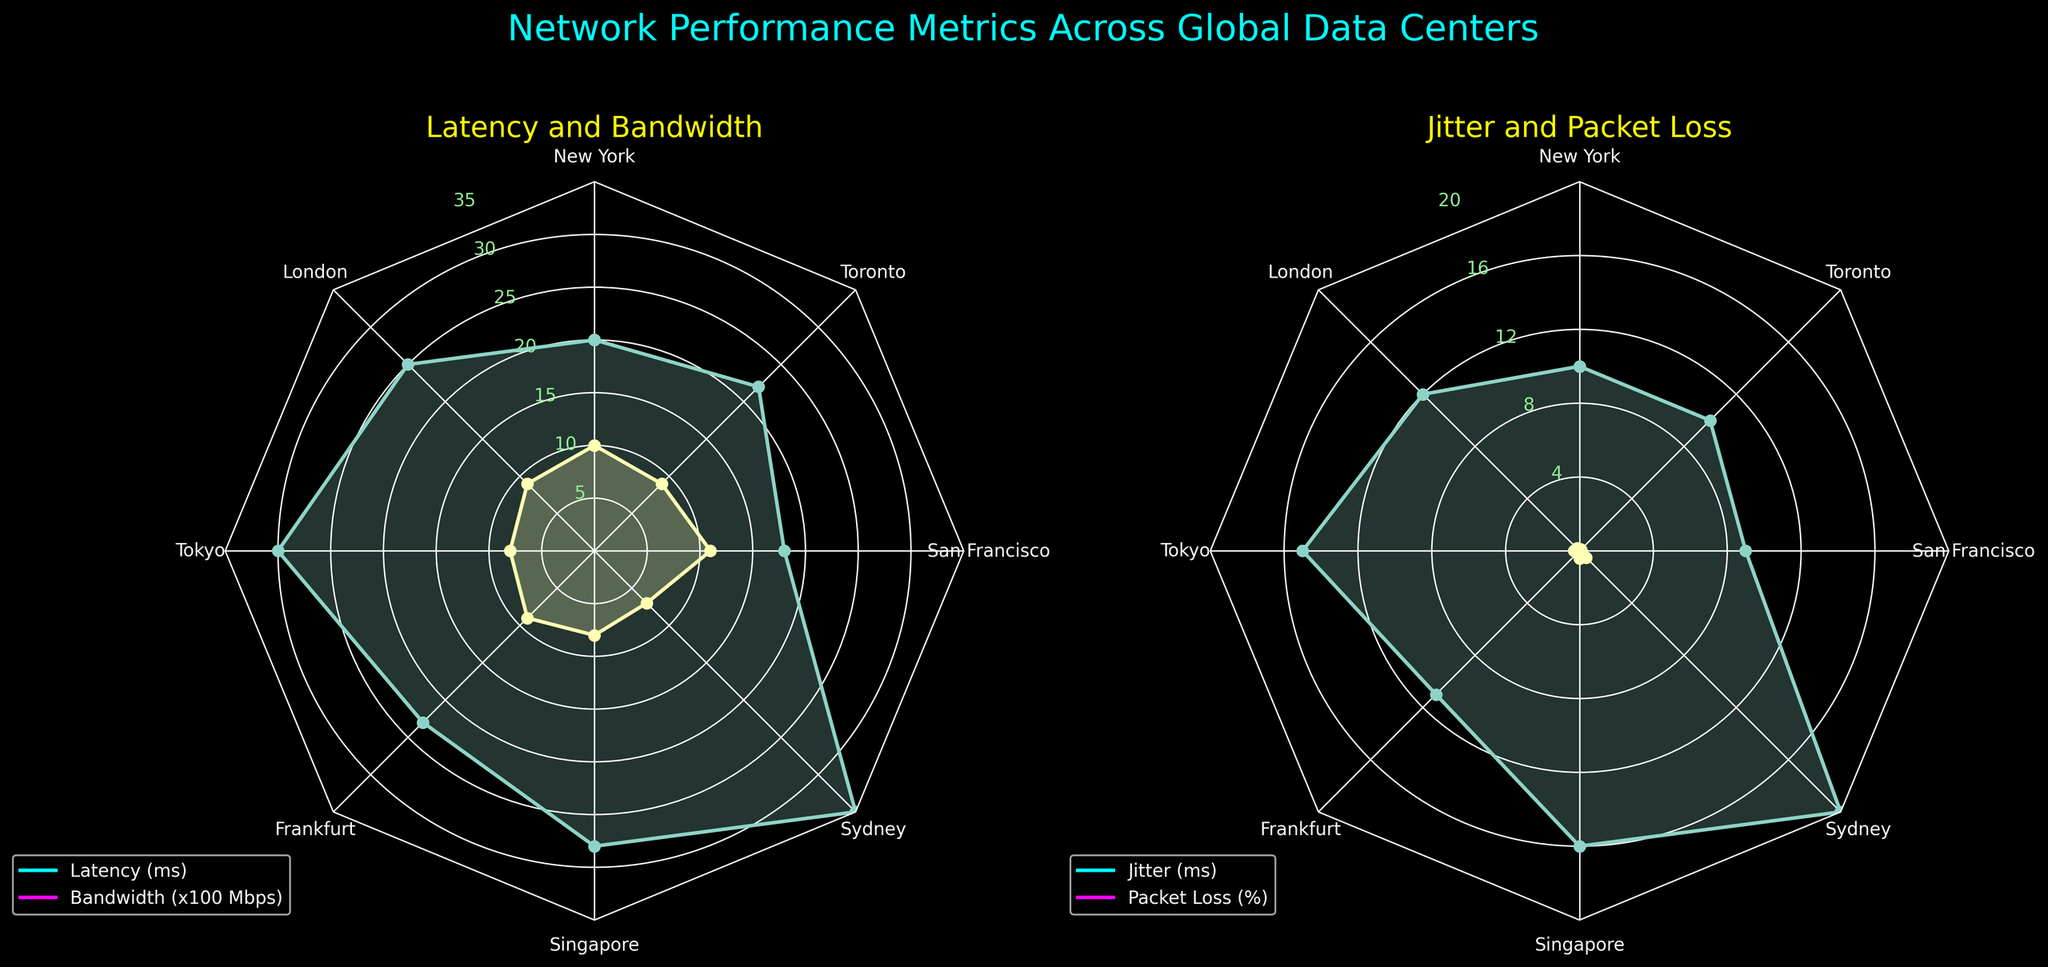Which location has the lowest latency? By looking at the "Latency and Bandwidth" radar chart, find the location which has the smallest value for latency. The marker representing San Francisco is the closest to the center.
Answer: San Francisco Which location has the highest packet loss? By inspecting the "Jitter and Packet Loss" radar chart, identify the location with the outermost point on the Packet Loss axis. The data point farthest from the center is for Sydney.
Answer: Sydney What is the title of the figure? The title of the figure is located at the top of the image.
Answer: Network Performance Metrics Across Global Data Centers What is the average bandwidth across all locations? Sum the bandwidth for all locations and divide by the number of locations. The values 1000, 900, 850, 950, 800, 750, 1100, and 980 sum to 7330, divided by 8 gives 916.25.
Answer: 916.25 Mbps Which location has higher bandwidth, New York or Tokyo? Compare the position of New York and Tokyo on the Bandwidth axis in the "Latency and Bandwidth" radar chart. New York is closer to the outer circle than Tokyo.
Answer: New York How is jitter distributed among the locations? Review the “Jitter and Packet Loss” radar chart and observe the distances from the center to the Jitter markers across all locations.
Answer: Ranges from 9 ms in San Francisco to 20 ms in Sydney What is the sum of latency in London and Frankfurt? Add the values of latency for London (25 ms) and Frankfurt (23 ms). 25 + 23 equals 48 ms.
Answer: 48 ms Is Toronto's latency more or less than the average latency? First, calculate the average latency by summing all latency values (20, 25, 30, 23, 28, 35, 18, 22) which equals 201 ms, divided by 8 gives 25.125 ms. Toronto’s latency is 22 ms. 22 is less than 25.125.
Answer: Less Identify the location with the least jitter and least packet loss. On the "Jitter and Packet Loss" radar chart, check the location closest to the center for both metrics. San Francisco has the least jitter (9 ms) and minimal packet loss (0.1%).
Answer: San Francisco What color is used for labeling the tick values on both radar charts? Observe the color of the numbers on both radar charts representing different tick values along the radius.
Answer: Light green 